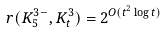<formula> <loc_0><loc_0><loc_500><loc_500>r ( K _ { 5 } ^ { 3 - } , K _ { t } ^ { 3 } ) = 2 ^ { O ( t ^ { 2 } \log t ) }</formula> 